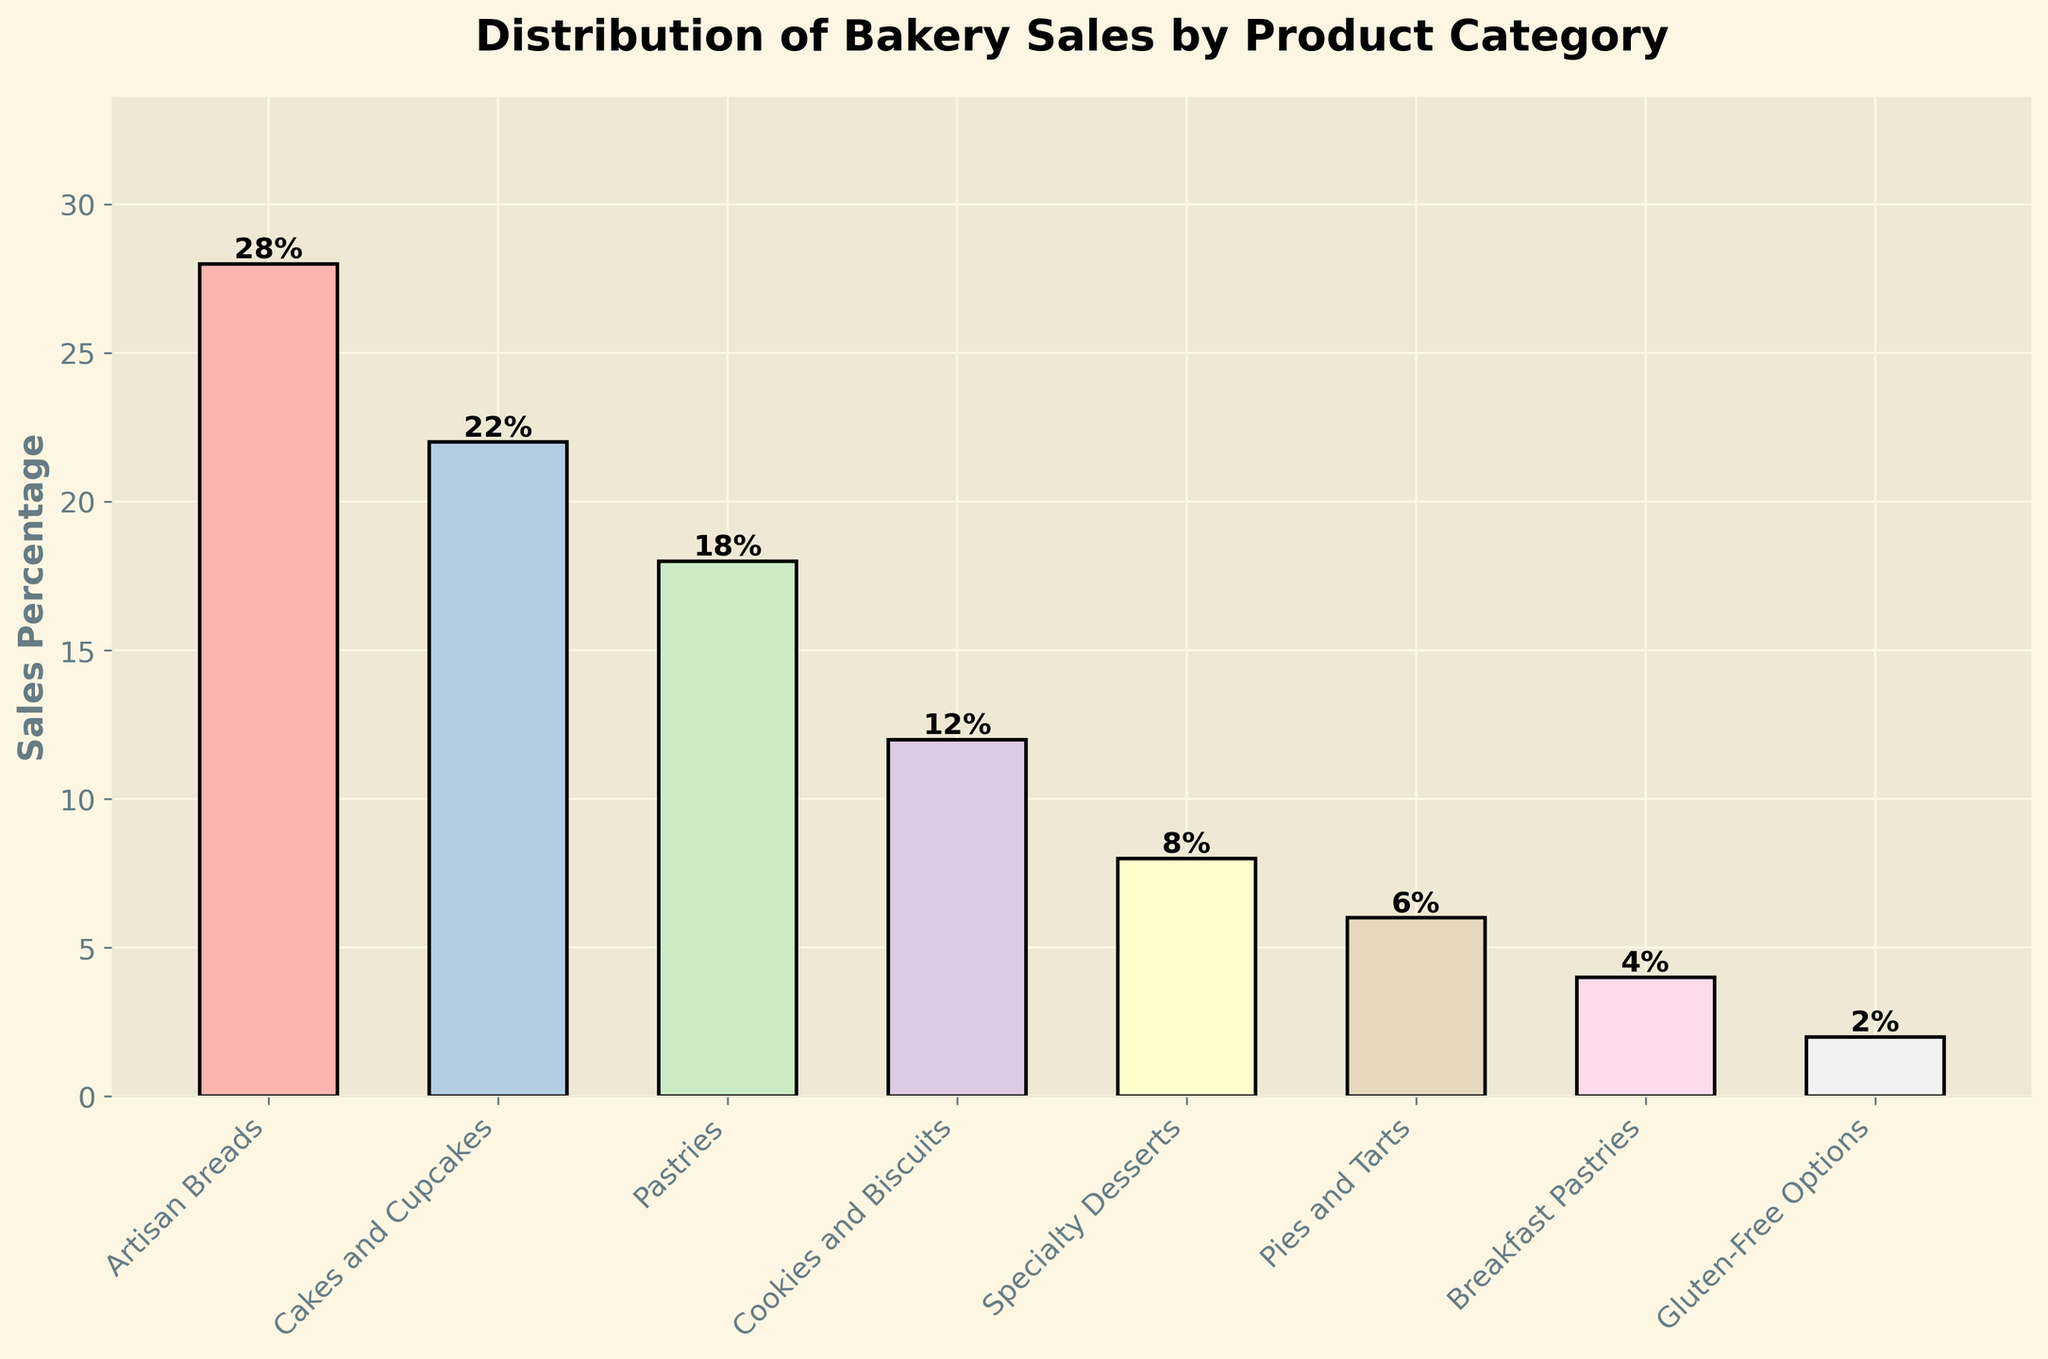What's the most popular product category in the bakery? The tallest bar in the chart represents the product category with the highest percentage of sales. The "Artisan Breads" bar is the tallest.
Answer: Artisan Breads Which product category has the smallest share of sales? The shortest bar represents the category with the smallest sales percentage. The "Gluten-Free Options" bar is the shortest.
Answer: Gluten-Free Options What is the difference in sales percentage between "Artisan Breads" and "Cakes and Cupcakes"? Subtract the sales percentage of "Cakes and Cupcakes" (22%) from "Artisan Breads" (28%). That is 28% - 22% = 6%.
Answer: 6% How do the sales percentages of "Pastries" and "Cookies and Biscuits" compare? The bar for "Pastries" is taller compared to the "Cookies and Biscuits" bar. The sales percentage for "Pastries" is 18%, and for "Cookies and Biscuits" it is 12%. So, "Pastries" have a higher sales percentage by 6%.
Answer: Pastries have a higher sales percentage What is the combined sales percentage for "Specialty Desserts" and "Pies and Tarts"? Add the sales percentages of "Specialty Desserts" (8%) and "Pies and Tarts" (6%). That is 8% + 6% = 14%.
Answer: 14% Which product category has twice the sales percentage of "Breakfast Pastries"? The sales percentage for "Breakfast Pastries" is 4%. The bar showing double this percentage would be 8%. "Specialty Desserts" has an 8% sales percentage.
Answer: Specialty Desserts What percentage of the sales is made up by "Artisan Breads" and "Cookies and Biscuits" together? Add the sales percentages of "Artisan Breads" (28%) and "Cookies and Biscuits" (12%). That is 28% + 12% = 40%.
Answer: 40% Are there any product categories with sales percentages below 5%? If yes, which ones? Identify any bars that are shorter and represent less than a 5% sales percentage. The "Breakfast Pastries" (4%) and "Gluten-Free Options" (2%) bars fit this criterion.
Answer: Breakfast Pastries and Gluten-Free Options What is the total sales percentage for "Pastries," "Cookies and Biscuits," and "Specialty Desserts"? Add the sales percentages of "Pastries" (18%), "Cookies and Biscuits" (12%), and "Specialty Desserts" (8%). That is 18% + 12% + 8% = 38%.
Answer: 38% 